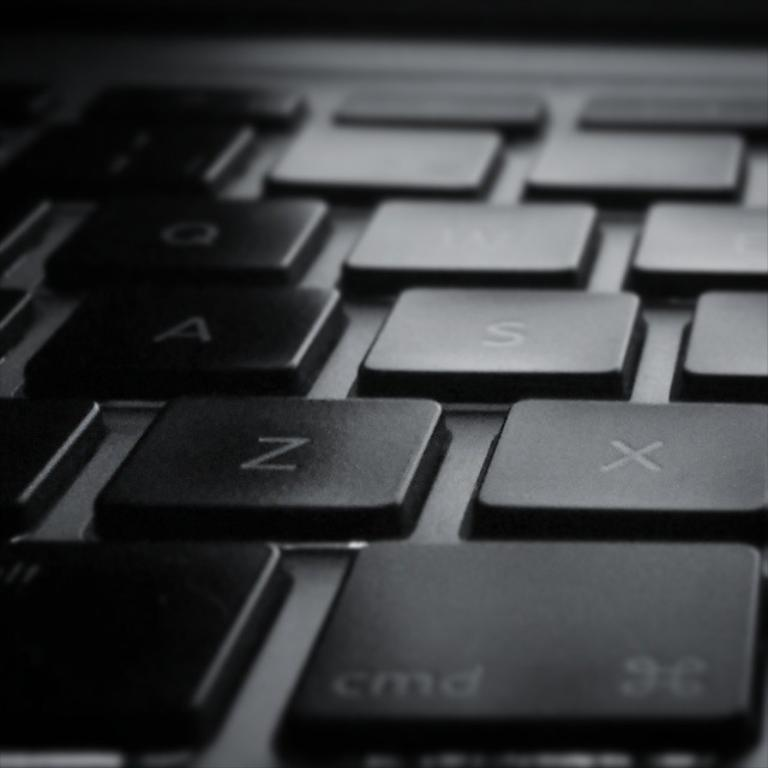<image>
Create a compact narrative representing the image presented. close up of a section of a keyboard with the cmd, z, x, a, and s keys visible 